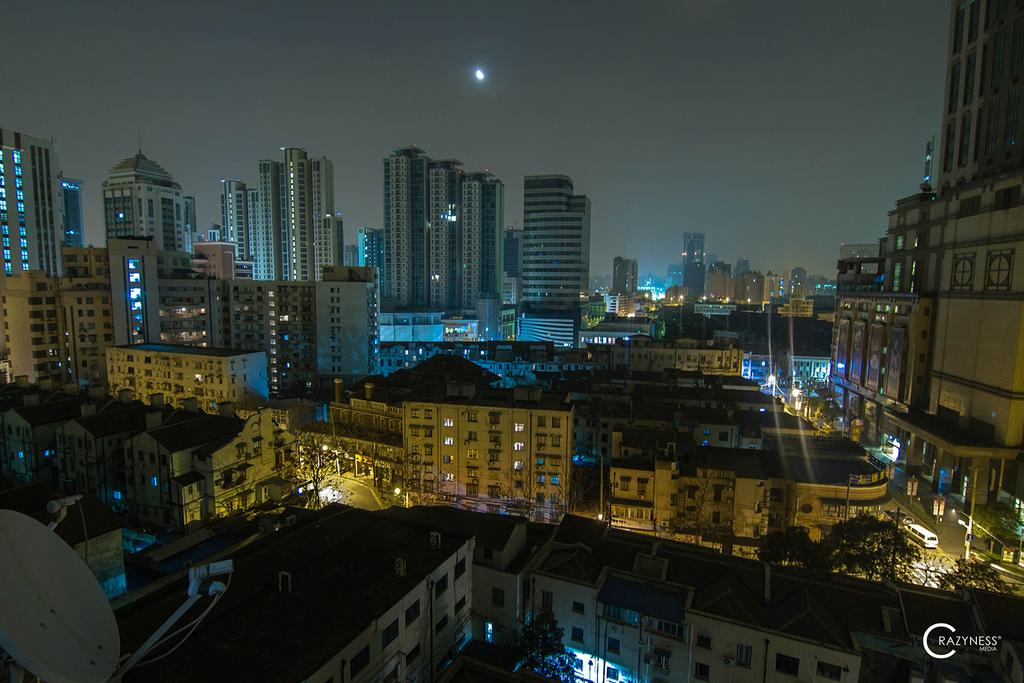What type of structures can be seen in the image? There are buildings in the image. What else is visible in the image besides the buildings? There are lights, poles, trees, hoardings, and text in the bottom right-hand corner of the image. What type of cheese is being sold in the basket in the image? There is no cheese or basket present in the image. Can you see an airplane flying in the image? There is no airplane visible in the image. 